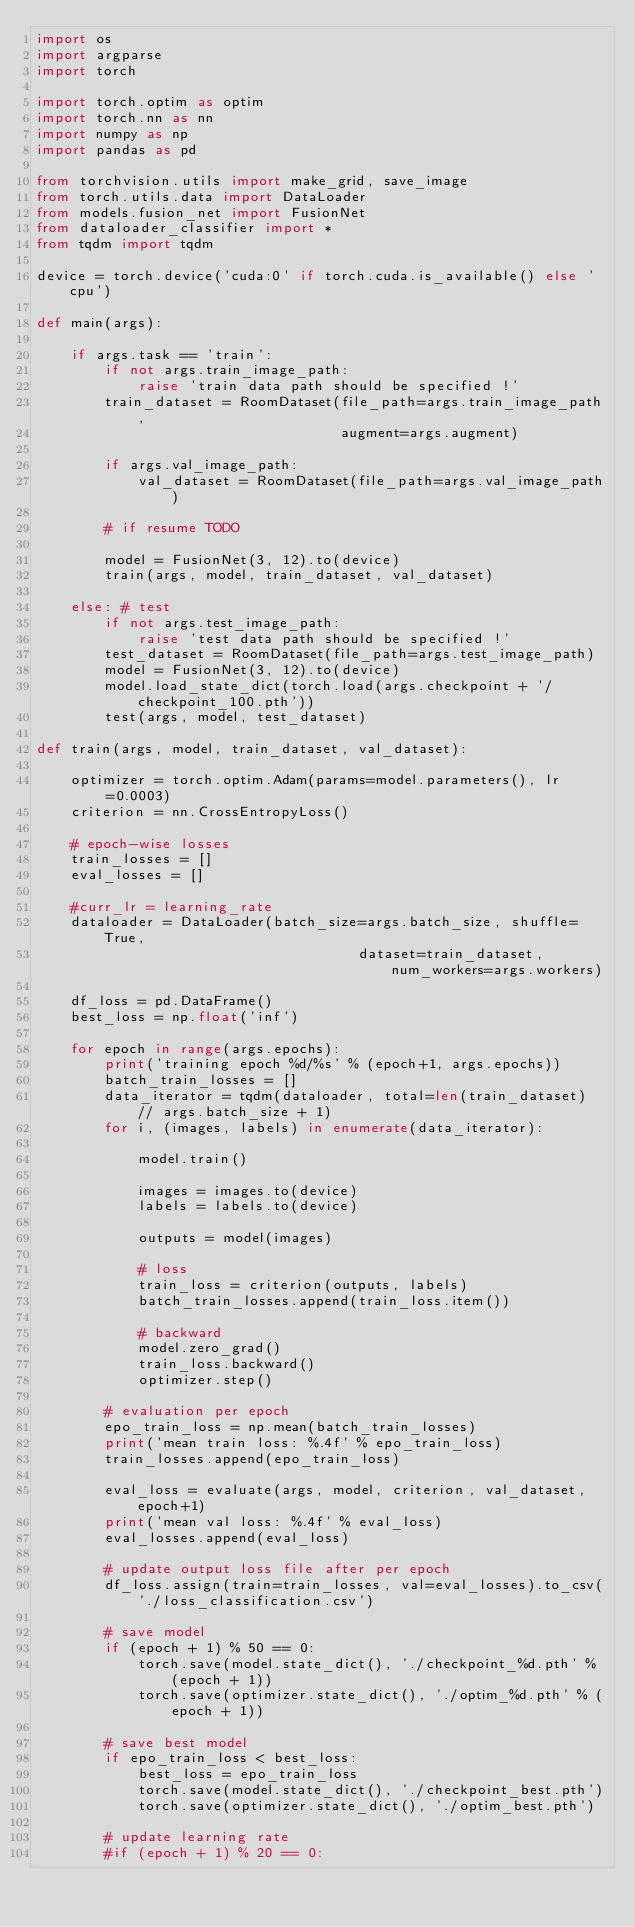Convert code to text. <code><loc_0><loc_0><loc_500><loc_500><_Python_>import os
import argparse
import torch

import torch.optim as optim
import torch.nn as nn
import numpy as np
import pandas as pd

from torchvision.utils import make_grid, save_image
from torch.utils.data import DataLoader
from models.fusion_net import FusionNet
from dataloader_classifier import *
from tqdm import tqdm

device = torch.device('cuda:0' if torch.cuda.is_available() else 'cpu')

def main(args):

    if args.task == 'train':
        if not args.train_image_path:
            raise 'train data path should be specified !'
        train_dataset = RoomDataset(file_path=args.train_image_path,
                                    augment=args.augment)

        if args.val_image_path:
            val_dataset = RoomDataset(file_path=args.val_image_path)

        # if resume TODO

        model = FusionNet(3, 12).to(device)
        train(args, model, train_dataset, val_dataset)

    else: # test
        if not args.test_image_path: 
            raise 'test data path should be specified !'
        test_dataset = RoomDataset(file_path=args.test_image_path)
        model = FusionNet(3, 12).to(device)
        model.load_state_dict(torch.load(args.checkpoint + '/checkpoint_100.pth'))
        test(args, model, test_dataset)

def train(args, model, train_dataset, val_dataset):

    optimizer = torch.optim.Adam(params=model.parameters(), lr=0.0003)
    criterion = nn.CrossEntropyLoss()

    # epoch-wise losses
    train_losses = []
    eval_losses = []

    #curr_lr = learning_rate
    dataloader = DataLoader(batch_size=args.batch_size, shuffle=True,
                                      dataset=train_dataset, num_workers=args.workers)
    
    df_loss = pd.DataFrame()
    best_loss = np.float('inf')

    for epoch in range(args.epochs):
        print('training epoch %d/%s' % (epoch+1, args.epochs))
        batch_train_losses = []
        data_iterator = tqdm(dataloader, total=len(train_dataset) // args.batch_size + 1)
        for i, (images, labels) in enumerate(data_iterator):
        
            model.train()
        
            images = images.to(device)
            labels = labels.to(device)
        
            outputs = model(images)
    
            # loss
            train_loss = criterion(outputs, labels)
            batch_train_losses.append(train_loss.item())
        
            # backward
            model.zero_grad()
            train_loss.backward()
            optimizer.step()
        
        # evaluation per epoch
        epo_train_loss = np.mean(batch_train_losses)
        print('mean train loss: %.4f' % epo_train_loss)
        train_losses.append(epo_train_loss)
        
        eval_loss = evaluate(args, model, criterion, val_dataset, epoch+1)
        print('mean val loss: %.4f' % eval_loss)
        eval_losses.append(eval_loss)
        
        # update output loss file after per epoch
        df_loss.assign(train=train_losses, val=eval_losses).to_csv('./loss_classification.csv')

        # save model    
        if (epoch + 1) % 50 == 0:
            torch.save(model.state_dict(), './checkpoint_%d.pth' % (epoch + 1))
            torch.save(optimizer.state_dict(), './optim_%d.pth' % (epoch + 1))

        # save best model    
        if epo_train_loss < best_loss:
            best_loss = epo_train_loss
            torch.save(model.state_dict(), './checkpoint_best.pth')
            torch.save(optimizer.state_dict(), './optim_best.pth')
        
        # update learning rate
        #if (epoch + 1) % 20 == 0:</code> 